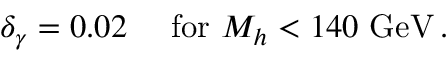<formula> <loc_0><loc_0><loc_500><loc_500>\delta _ { \gamma } = 0 . 0 2 \quad f o r M _ { h } < 1 4 0 G e V \, .</formula> 